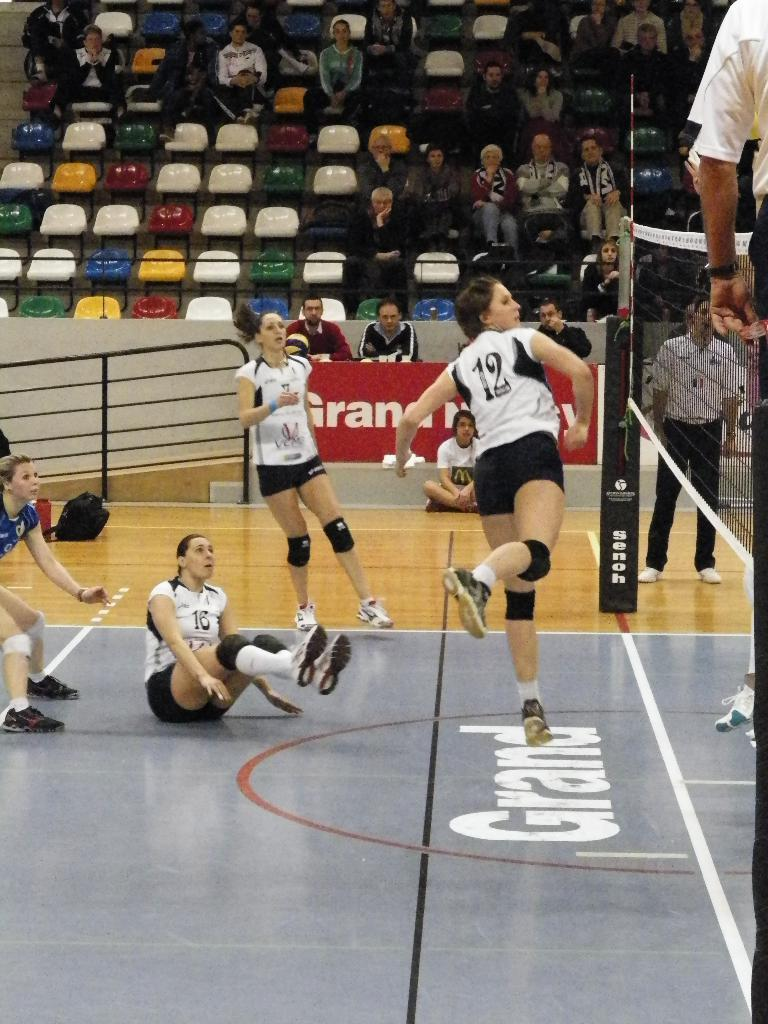What activity are the people in the image engaged in? There is a group of people playing a game in the image. Can you describe the setting of the image? There is a group of people sitting in the background of the image. What feature can be seen in the image that might indicate a specific location or setting? There is railing visible in the image. What type of polish is being applied to the bear in the image? There is no bear or polish present in the image. What adjustment needs to be made to the railing in the image? There is no indication in the image that any adjustment needs to be made to the railing. 